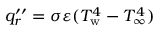Convert formula to latex. <formula><loc_0><loc_0><loc_500><loc_500>q _ { r } ^ { \prime \prime } = \sigma \varepsilon ( T _ { w } ^ { 4 } - T _ { \infty } ^ { 4 } )</formula> 